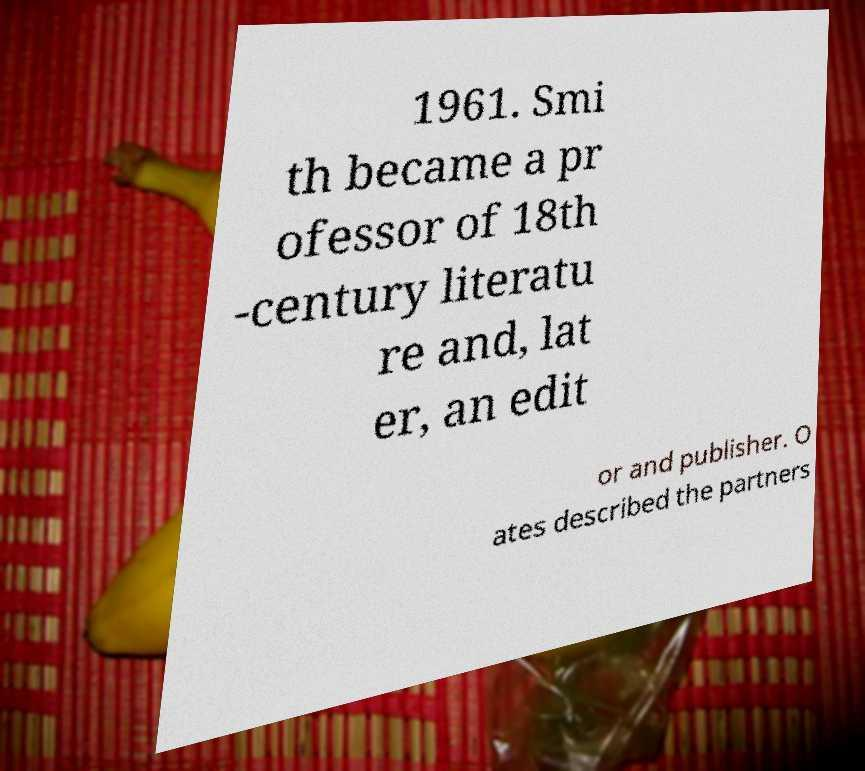Could you assist in decoding the text presented in this image and type it out clearly? 1961. Smi th became a pr ofessor of 18th -century literatu re and, lat er, an edit or and publisher. O ates described the partners 